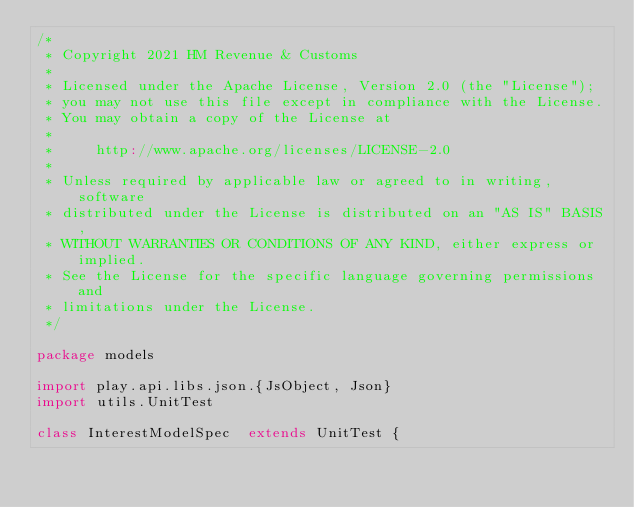Convert code to text. <code><loc_0><loc_0><loc_500><loc_500><_Scala_>/*
 * Copyright 2021 HM Revenue & Customs
 *
 * Licensed under the Apache License, Version 2.0 (the "License");
 * you may not use this file except in compliance with the License.
 * You may obtain a copy of the License at
 *
 *     http://www.apache.org/licenses/LICENSE-2.0
 *
 * Unless required by applicable law or agreed to in writing, software
 * distributed under the License is distributed on an "AS IS" BASIS,
 * WITHOUT WARRANTIES OR CONDITIONS OF ANY KIND, either express or implied.
 * See the License for the specific language governing permissions and
 * limitations under the License.
 */

package models

import play.api.libs.json.{JsObject, Json}
import utils.UnitTest

class InterestModelSpec  extends UnitTest {
</code> 